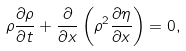<formula> <loc_0><loc_0><loc_500><loc_500>\rho \frac { \partial \rho } { \partial t } + \frac { \partial } { \partial x } \left ( \rho ^ { 2 } \frac { \partial \eta } { \partial x } \right ) = 0 ,</formula> 